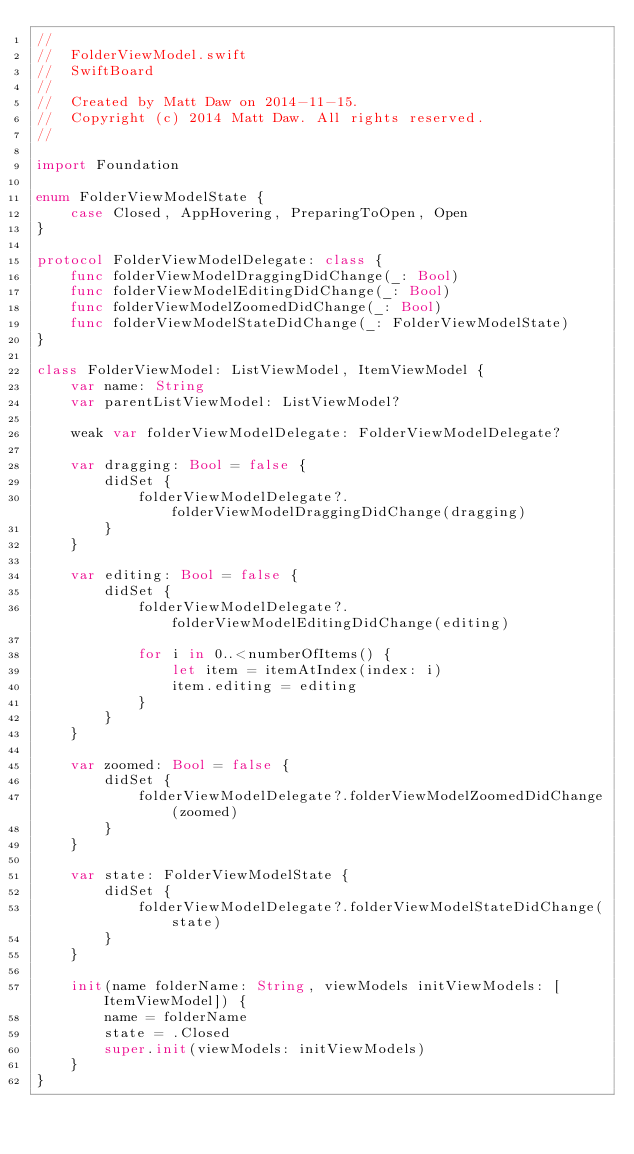<code> <loc_0><loc_0><loc_500><loc_500><_Swift_>//
//  FolderViewModel.swift
//  SwiftBoard
//
//  Created by Matt Daw on 2014-11-15.
//  Copyright (c) 2014 Matt Daw. All rights reserved.
//

import Foundation

enum FolderViewModelState {
    case Closed, AppHovering, PreparingToOpen, Open
}

protocol FolderViewModelDelegate: class {
    func folderViewModelDraggingDidChange(_: Bool)
    func folderViewModelEditingDidChange(_: Bool)
    func folderViewModelZoomedDidChange(_: Bool)
    func folderViewModelStateDidChange(_: FolderViewModelState)
}

class FolderViewModel: ListViewModel, ItemViewModel {
    var name: String
    var parentListViewModel: ListViewModel?
    
    weak var folderViewModelDelegate: FolderViewModelDelegate?
    
    var dragging: Bool = false {
        didSet {
            folderViewModelDelegate?.folderViewModelDraggingDidChange(dragging)
        }
    }
    
    var editing: Bool = false {
        didSet {
            folderViewModelDelegate?.folderViewModelEditingDidChange(editing)
        
            for i in 0..<numberOfItems() {
                let item = itemAtIndex(index: i)
                item.editing = editing
            }
        }
    }
    
    var zoomed: Bool = false {
        didSet {
            folderViewModelDelegate?.folderViewModelZoomedDidChange(zoomed)
        }
    }
    
    var state: FolderViewModelState {
        didSet {
            folderViewModelDelegate?.folderViewModelStateDidChange(state)
        }
    }
    
    init(name folderName: String, viewModels initViewModels: [ItemViewModel]) {
        name = folderName
        state = .Closed
        super.init(viewModels: initViewModels)
    }
}
</code> 